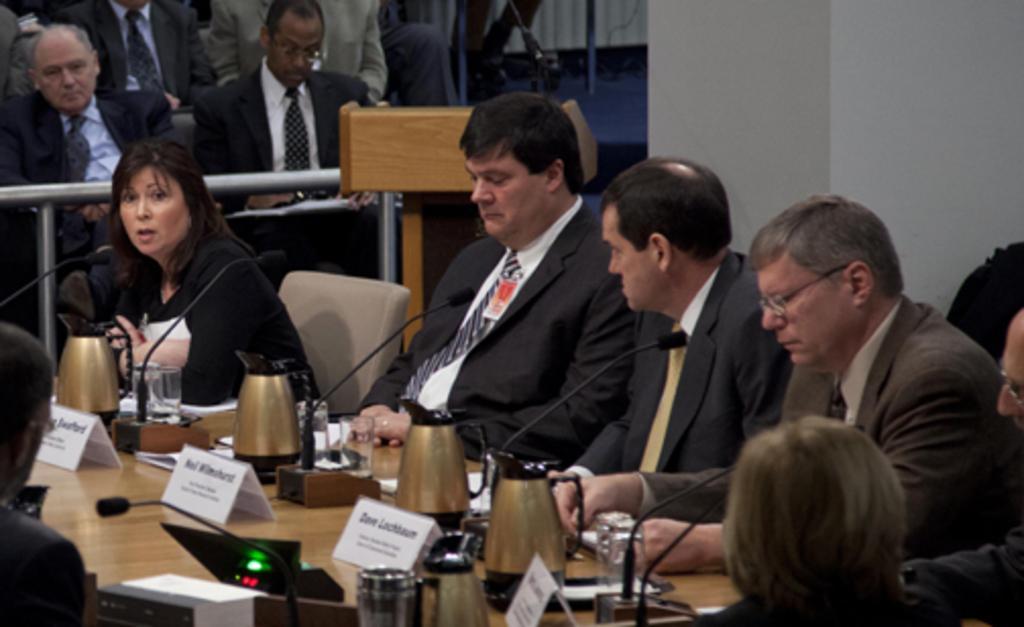Could you give a brief overview of what you see in this image? In this image, we can see persons wearing clothes. There is a table at the bottom of the image contains glasses, mugs and jugs. There is a metal barrier on the left side of the image. 